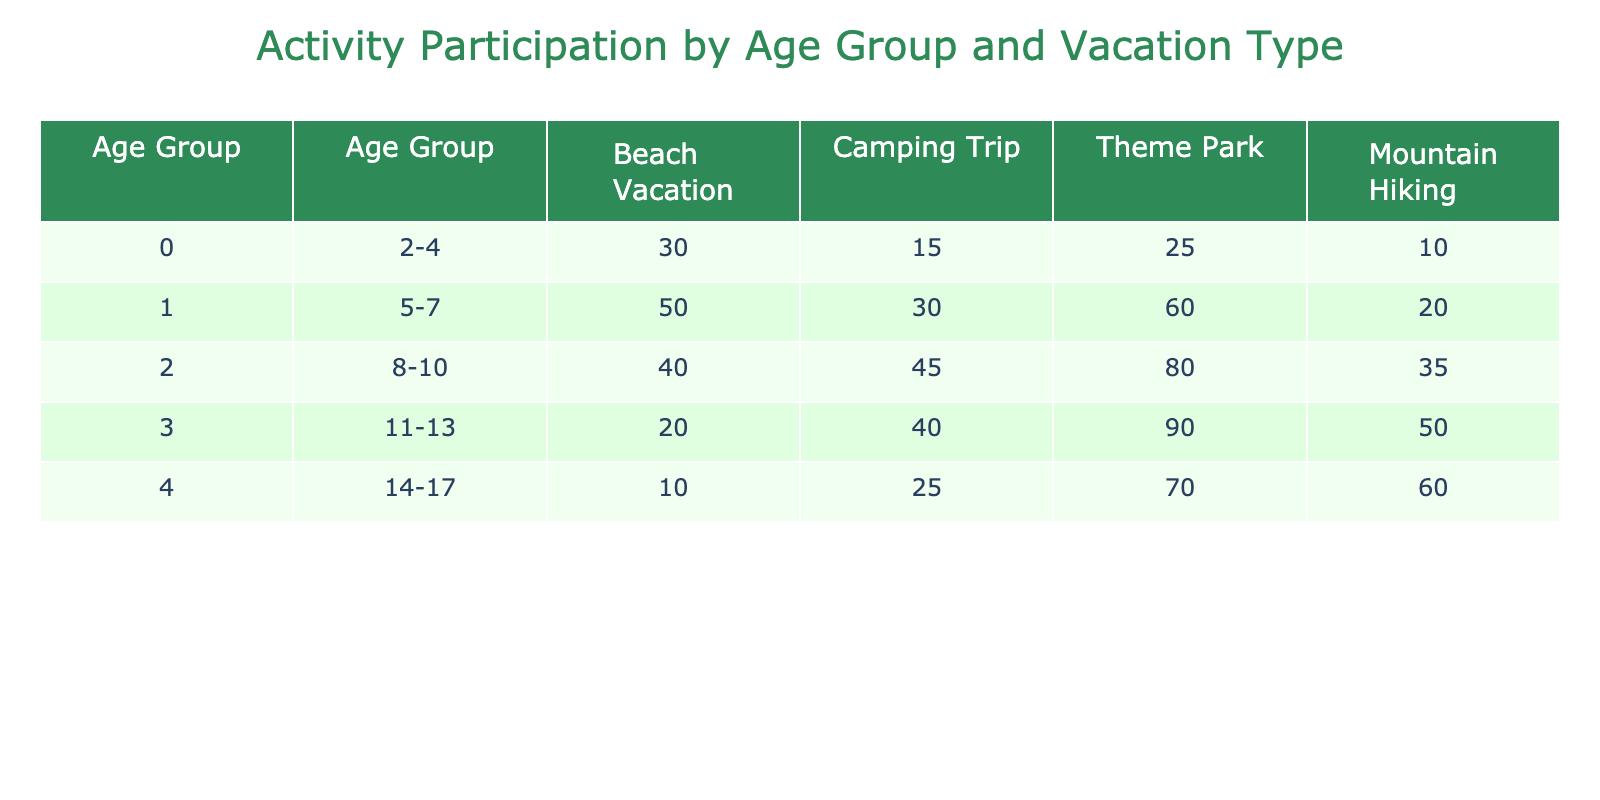What age group has the highest participation in Theme Park activities? Looking at the Theme Park column, the age group 11-13 has the highest participation with 90.
Answer: 11-13 Which vacation type sees the most participation from age group 5-7? In the table, for age group 5-7, the highest participation is in Theme Park activities with 60.
Answer: Theme Park What is the sum of participants in Camping Trip activities across all age groups? For Camping Trip, the participants are 15 + 30 + 45 + 40 + 25 = 155. Therefore, the total sum is 155.
Answer: 155 Is it true that more children aged 8-10 prefer Beach Vacations over Mountain Hiking? In the table, age group 8-10 has 40 for Beach Vacation and 35 for Mountain Hiking, meaning they do prefer Beach Vacations over Mountain Hiking.
Answer: Yes What is the average participation across the age groups for Beach Vacation activities? The sum of participants for Beach Vacation is 30 + 50 + 40 + 20 + 10 = 150. Dividing by the number of age groups (5), the average is 150 / 5 = 30.
Answer: 30 Which age group participates the least in Mountain Hiking activities? In the Mountain Hiking column, the age groups have the following participations: 10, 20, 35, 50, 60. The least is age group 2-4 with 10.
Answer: 2-4 How many more participants are there in Theme Park activities for age group 8-10 than for age group 14-17? For age group 8-10, there are 80 participants in Theme Park activities, and for age group 14-17, there are 70 participants. The difference is 80 - 70 = 10.
Answer: 10 What is the total participation for children aged 11-13 across all vacation types? Summing up the participants for age group 11-13 gives 20 + 40 + 90 + 50 = 200. Thus, the total participation is 200.
Answer: 200 Is it false that the total for Camping Trip activities exceeds that of Beach Vacation activities for any age group? The Camping Trip total across age groups is 155, while the Beach Vacation total is 150. Camping Trip exceeds Beach Vacation overall, so the statement is false.
Answer: No 